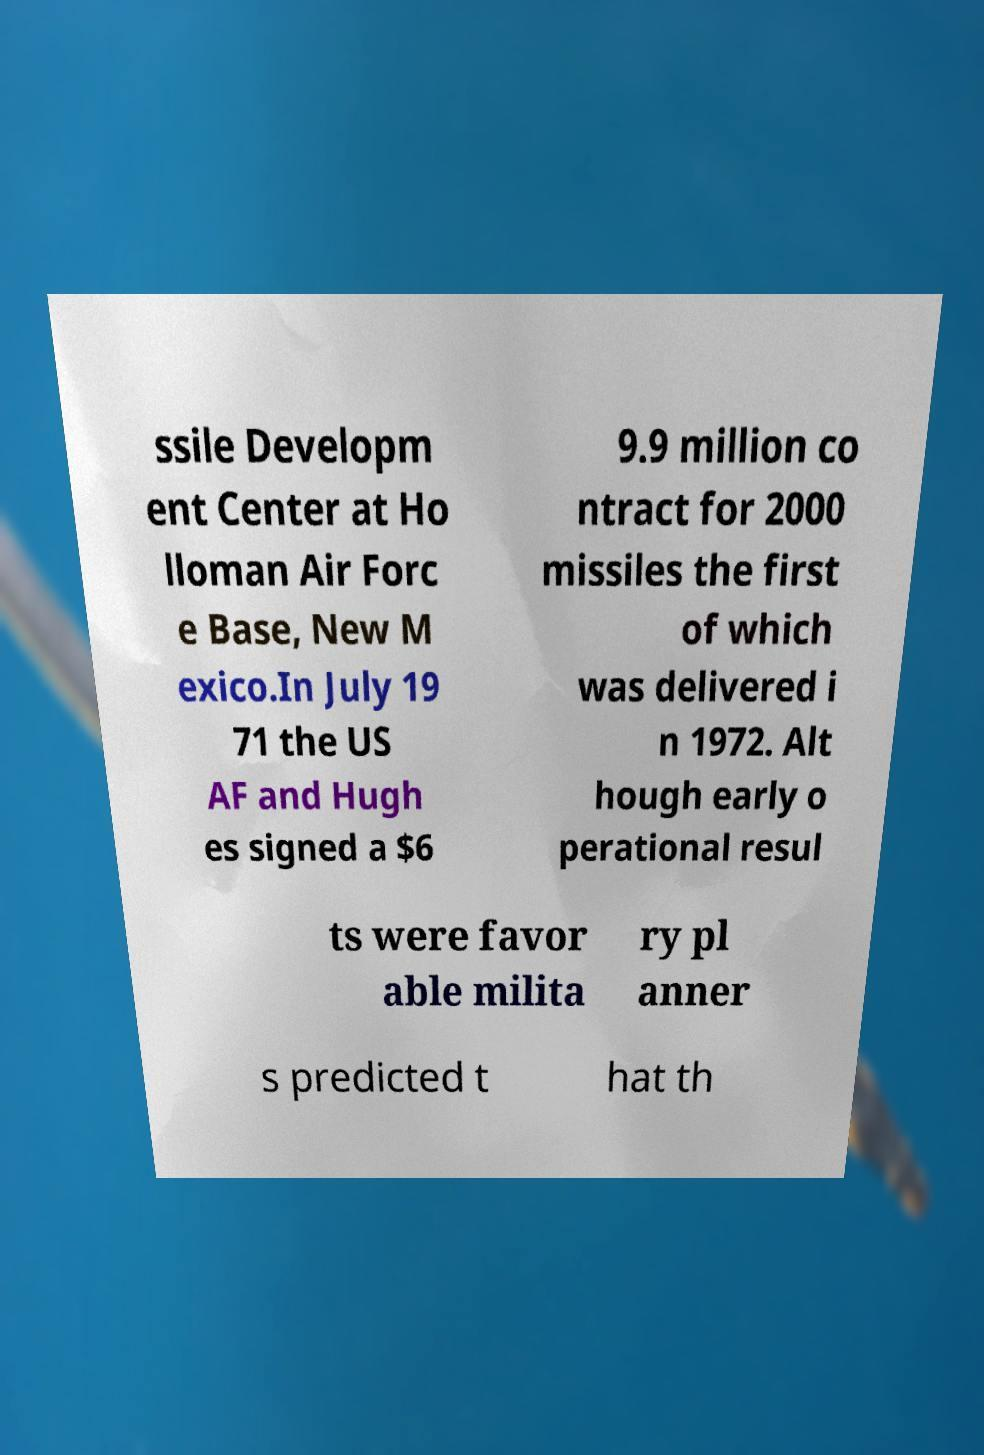For documentation purposes, I need the text within this image transcribed. Could you provide that? ssile Developm ent Center at Ho lloman Air Forc e Base, New M exico.In July 19 71 the US AF and Hugh es signed a $6 9.9 million co ntract for 2000 missiles the first of which was delivered i n 1972. Alt hough early o perational resul ts were favor able milita ry pl anner s predicted t hat th 